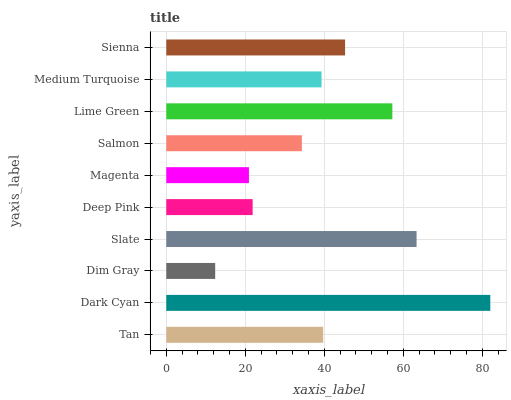Is Dim Gray the minimum?
Answer yes or no. Yes. Is Dark Cyan the maximum?
Answer yes or no. Yes. Is Dark Cyan the minimum?
Answer yes or no. No. Is Dim Gray the maximum?
Answer yes or no. No. Is Dark Cyan greater than Dim Gray?
Answer yes or no. Yes. Is Dim Gray less than Dark Cyan?
Answer yes or no. Yes. Is Dim Gray greater than Dark Cyan?
Answer yes or no. No. Is Dark Cyan less than Dim Gray?
Answer yes or no. No. Is Tan the high median?
Answer yes or no. Yes. Is Medium Turquoise the low median?
Answer yes or no. Yes. Is Magenta the high median?
Answer yes or no. No. Is Dim Gray the low median?
Answer yes or no. No. 